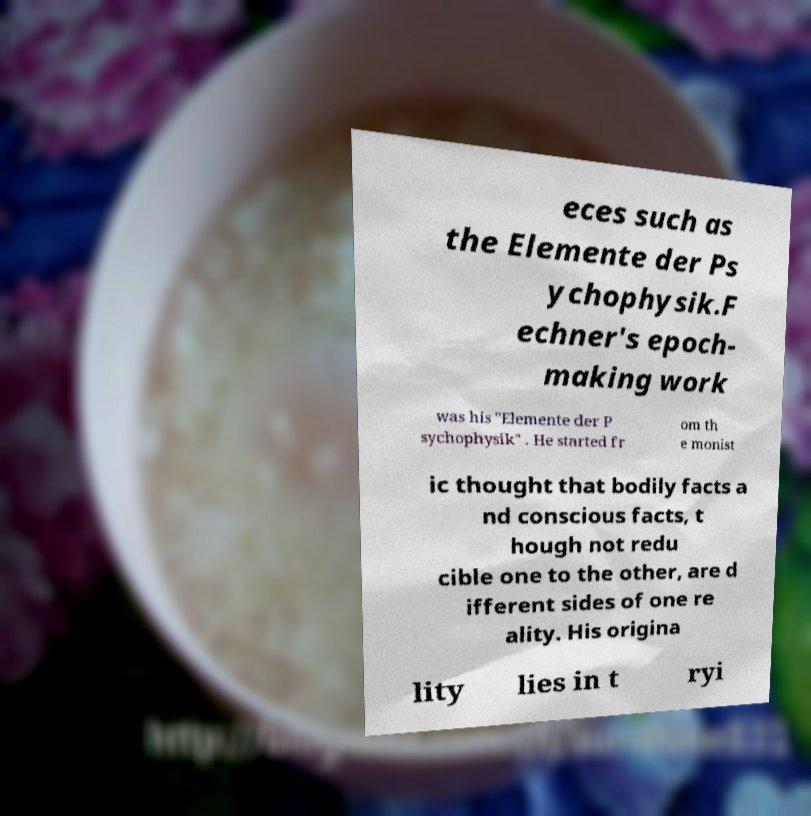Please read and relay the text visible in this image. What does it say? eces such as the Elemente der Ps ychophysik.F echner's epoch- making work was his "Elemente der P sychophysik" . He started fr om th e monist ic thought that bodily facts a nd conscious facts, t hough not redu cible one to the other, are d ifferent sides of one re ality. His origina lity lies in t ryi 